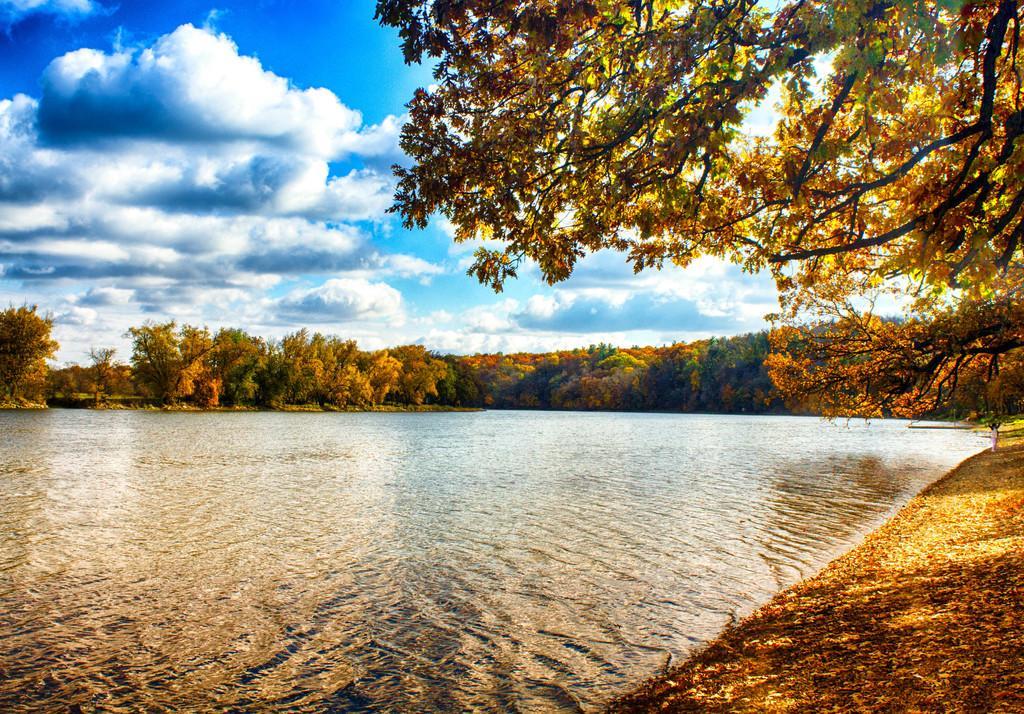Could you give a brief overview of what you see in this image? In this image there are trees and we can see water. In the background there is sky. 